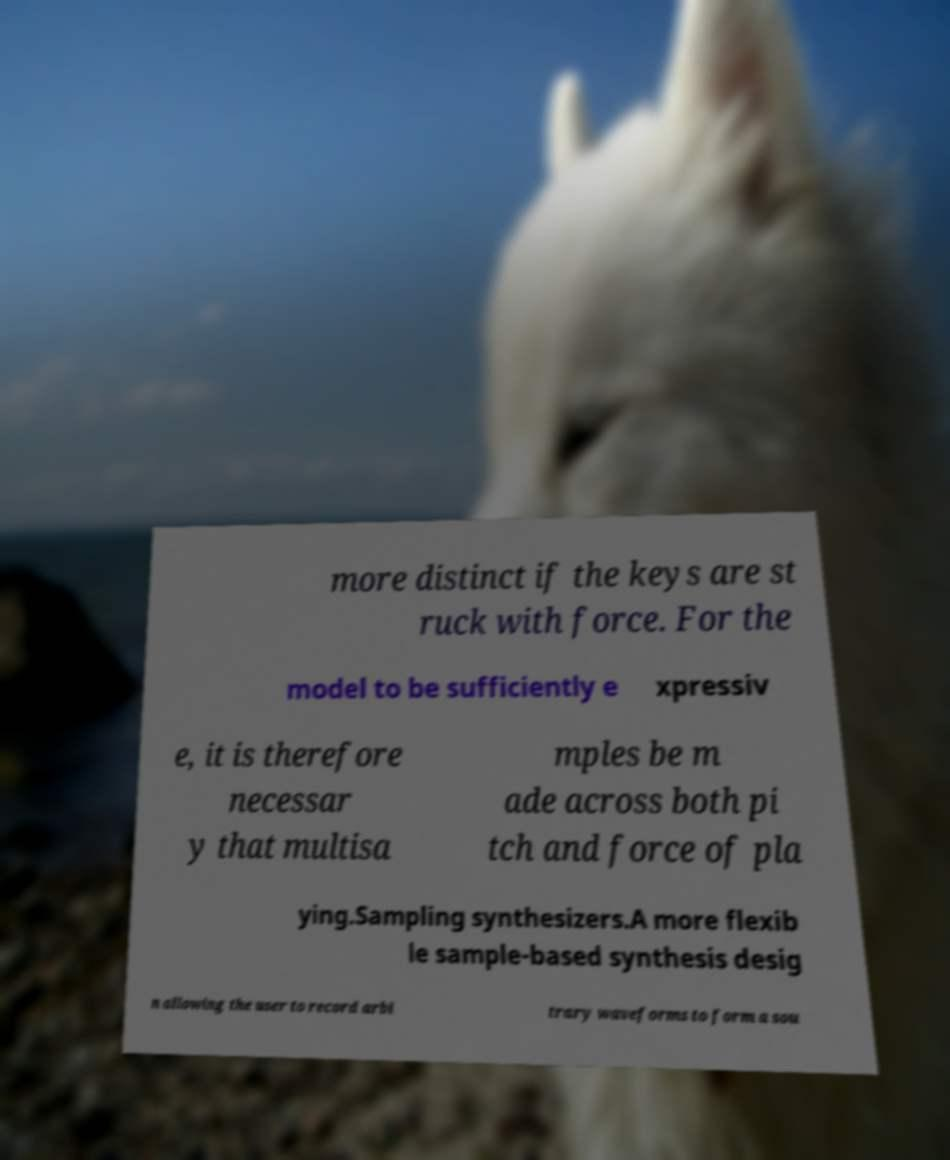What messages or text are displayed in this image? I need them in a readable, typed format. more distinct if the keys are st ruck with force. For the model to be sufficiently e xpressiv e, it is therefore necessar y that multisa mples be m ade across both pi tch and force of pla ying.Sampling synthesizers.A more flexib le sample-based synthesis desig n allowing the user to record arbi trary waveforms to form a sou 